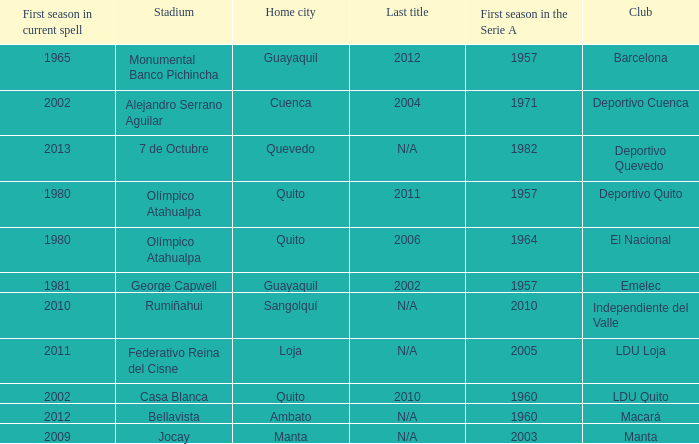Name the club for quevedo Deportivo Quevedo. 